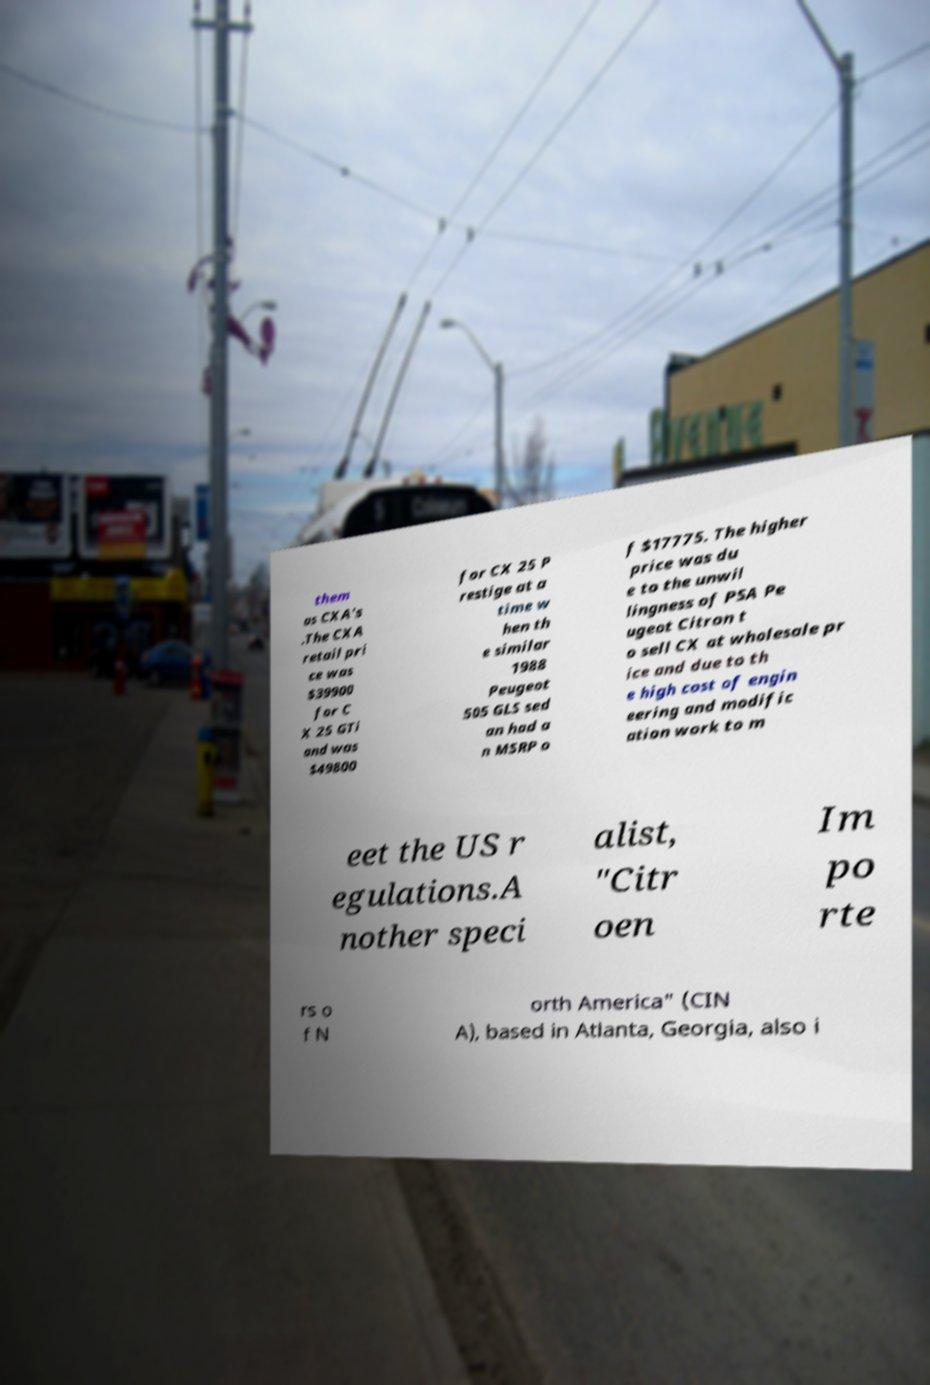There's text embedded in this image that I need extracted. Can you transcribe it verbatim? them as CXA's .The CXA retail pri ce was $39900 for C X 25 GTi and was $49800 for CX 25 P restige at a time w hen th e similar 1988 Peugeot 505 GLS sed an had a n MSRP o f $17775. The higher price was du e to the unwil lingness of PSA Pe ugeot Citron t o sell CX at wholesale pr ice and due to th e high cost of engin eering and modific ation work to m eet the US r egulations.A nother speci alist, "Citr oen Im po rte rs o f N orth America" (CIN A), based in Atlanta, Georgia, also i 